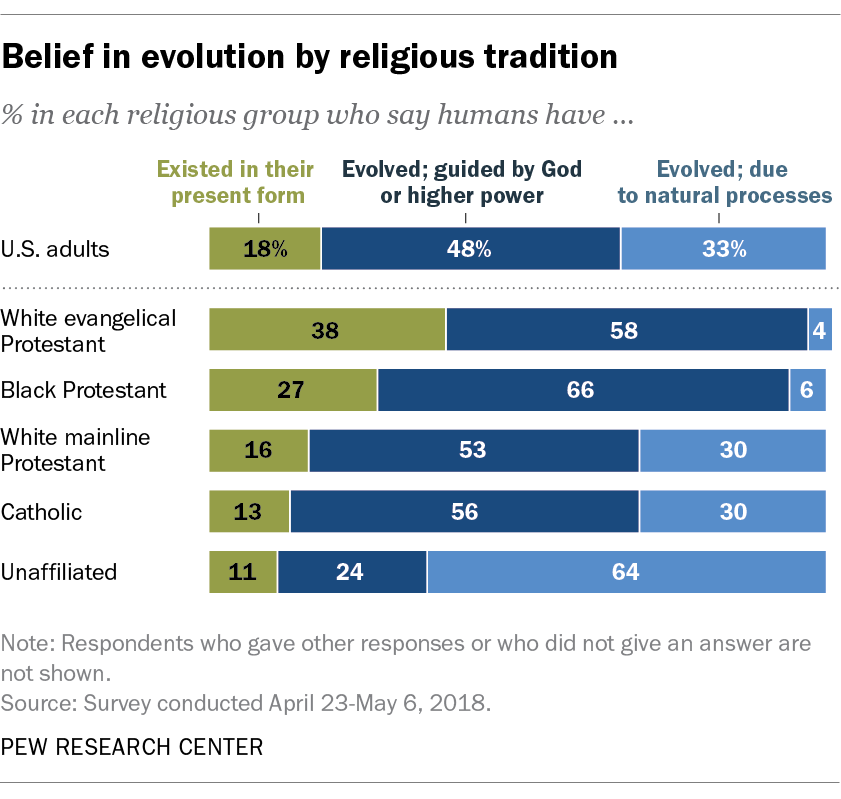Indicate a few pertinent items in this graphic. The blue bar has evolved due to natural processes. The sum value of Catholic and White mainline Protestants in their present form is 29. 